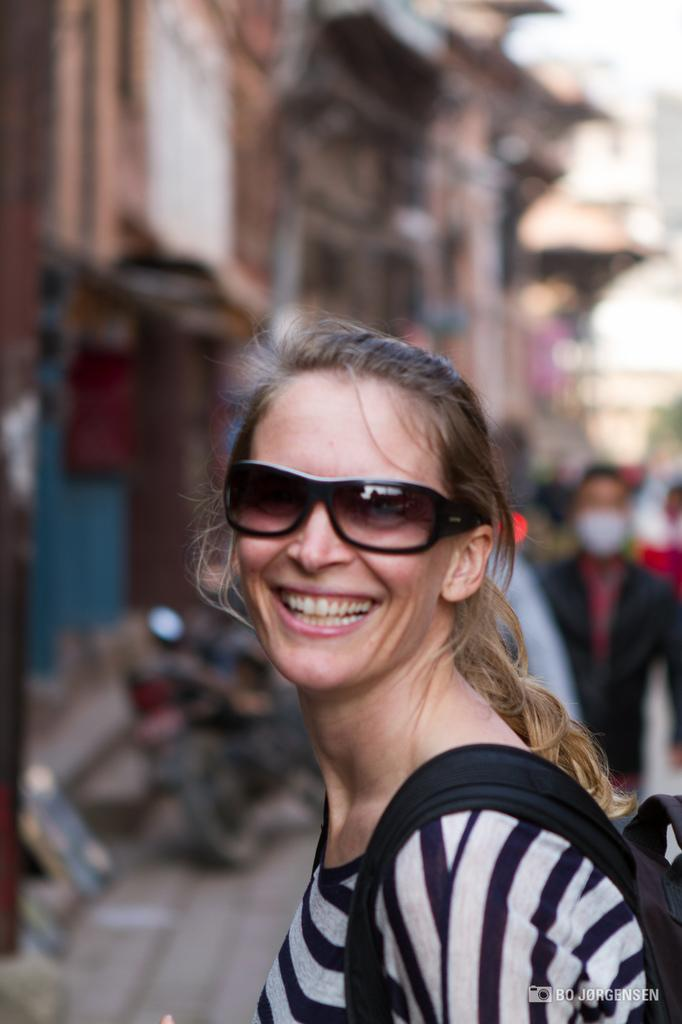Who is the main subject in the image? There is a woman in the center of the image. What is the woman wearing? The woman is wearing spectacles. What is the woman carrying? The woman is carrying a bag. What can be seen in the background of the image? There is a vehicle, buildings, persons, and the sky visible in the background of the image. What type of payment method is the woman using in the image? There is no indication of any payment method being used in the image. 